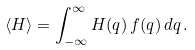Convert formula to latex. <formula><loc_0><loc_0><loc_500><loc_500>\langle H \rangle = \int ^ { \infty } _ { - \infty } H ( q ) \, f ( q ) \, d q \, .</formula> 